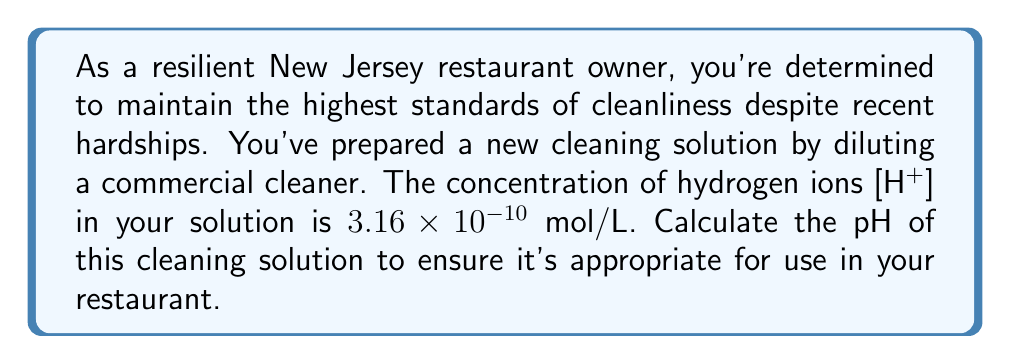Teach me how to tackle this problem. To solve this problem, we'll use the definition of pH and the properties of logarithms:

1) The pH is defined as the negative logarithm (base 10) of the hydrogen ion concentration:

   $$ pH = -\log_{10}[H^+] $$

2) We're given that $[H^+] = 3.16 \times 10^{-10}$ mol/L

3) Substituting this into the pH equation:

   $$ pH = -\log_{10}(3.16 \times 10^{-10}) $$

4) Using the properties of logarithms, we can split this into two parts:

   $$ pH = -(\log_{10}(3.16) + \log_{10}(10^{-10})) $$

5) $\log_{10}(3.16) \approx 0.4997$

6) $\log_{10}(10^{-10}) = -10$ (property of logarithms)

7) Therefore:

   $$ pH = -(\log_{10}(3.16) + (-10)) = -(0.4997 - 10) = 9.5003 $$

8) Rounding to two decimal places:

   $$ pH = 9.50 $$

This pH indicates a basic solution, which is typical for many cleaning products.
Answer: $9.50$ 